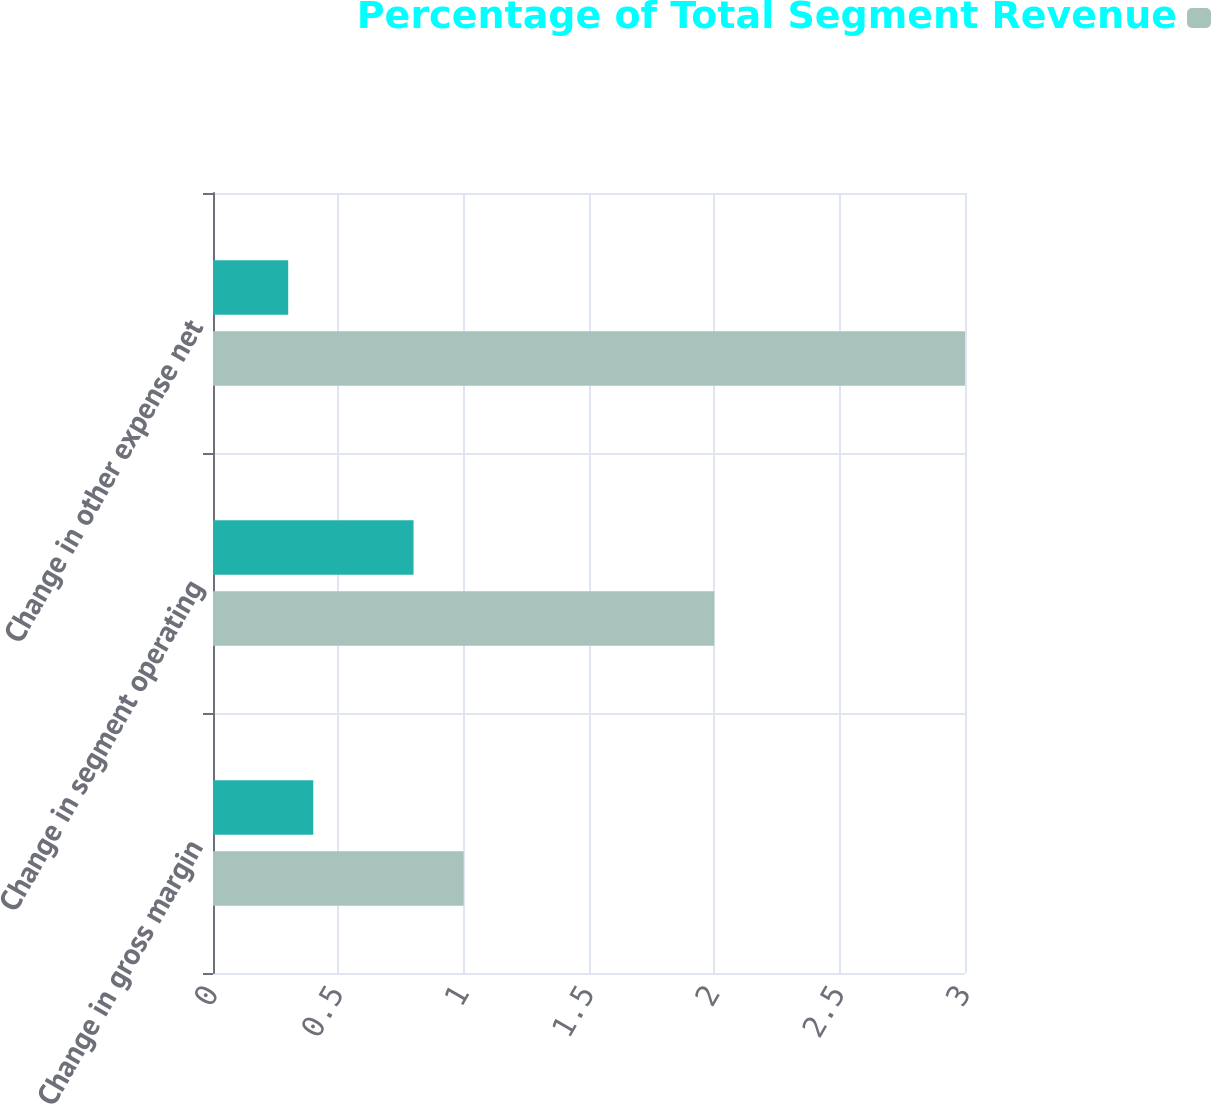Convert chart to OTSL. <chart><loc_0><loc_0><loc_500><loc_500><stacked_bar_chart><ecel><fcel>Change in gross margin<fcel>Change in segment operating<fcel>Change in other expense net<nl><fcel>nan<fcel>0.4<fcel>0.8<fcel>0.3<nl><fcel>Percentage of Total Segment Revenue<fcel>1<fcel>2<fcel>3<nl></chart> 